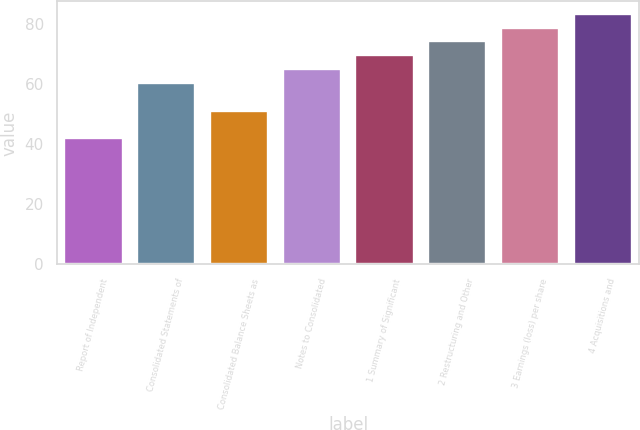<chart> <loc_0><loc_0><loc_500><loc_500><bar_chart><fcel>Report of Independent<fcel>Consolidated Statements of<fcel>Consolidated Balance Sheets as<fcel>Notes to Consolidated<fcel>1 Summary of Significant<fcel>2 Restructuring and Other<fcel>3 Earnings (loss) per share<fcel>4 Acquisitions and<nl><fcel>42<fcel>60.4<fcel>51.2<fcel>65<fcel>69.6<fcel>74.2<fcel>78.8<fcel>83.4<nl></chart> 